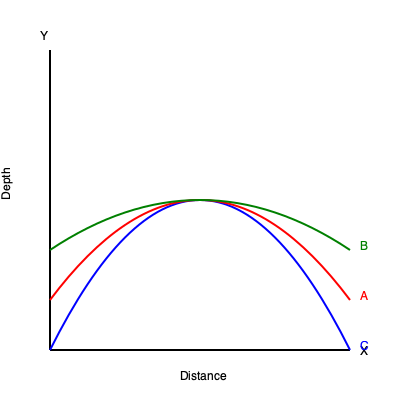As a petroleum geologist, you are analyzing a subsurface structure using contour lines. The diagram shows three isopach contours (A, B, and C) representing different depths. If the vertical distance between each contour is 50 meters, and the structure is symmetrical, what is the most likely type of trap formation represented, and what is the approximate closure (in meters) of this potential hydrocarbon trap? To determine the type of trap formation and calculate the closure, we need to follow these steps:

1. Identify the shape of the contours:
   The contours form a dome-like structure, with closed circular or elliptical shapes.

2. Recognize the trap type:
   The symmetric, dome-like structure is characteristic of an anticlinal trap, which is a common structural trap in petroleum geology.

3. Determine the closure:
   Closure is the vertical distance between the highest point of the structure and the spill point (lowest closing contour).

4. Calculate the closure:
   - Contour C (blue) represents the lowest depth
   - Contour A (red) represents the highest depth in the given structure
   - The vertical distance between each contour is 50 meters
   - There are two intervals between C and A
   - Closure = 2 * 50 meters = 100 meters

Therefore, the structure represents an anticlinal trap with an approximate closure of 100 meters.

This analysis provides valuable scientific data to support arguments for potential hydrocarbon accumulation in the identified structure.
Answer: Anticlinal trap with 100 meters closure 